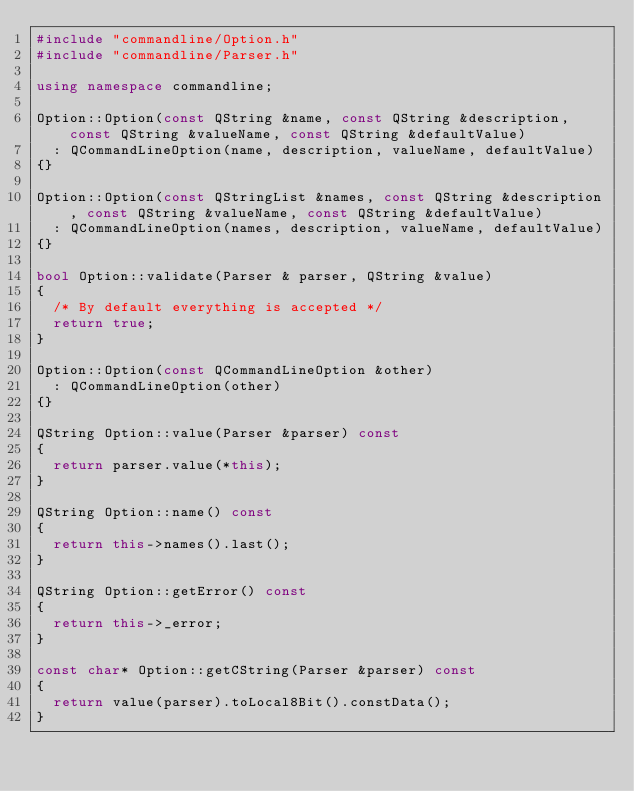Convert code to text. <code><loc_0><loc_0><loc_500><loc_500><_C++_>#include "commandline/Option.h"
#include "commandline/Parser.h"

using namespace commandline;

Option::Option(const QString &name, const QString &description, const QString &valueName, const QString &defaultValue)
	: QCommandLineOption(name, description, valueName, defaultValue)
{}

Option::Option(const QStringList &names, const QString &description, const QString &valueName, const QString &defaultValue)
	: QCommandLineOption(names, description, valueName, defaultValue)
{}

bool Option::validate(Parser & parser, QString &value)
{
	/* By default everything is accepted */
	return true;
}

Option::Option(const QCommandLineOption &other)
	: QCommandLineOption(other)
{}

QString Option::value(Parser &parser) const
{
	return parser.value(*this);
}

QString Option::name() const
{
	return this->names().last();
}

QString Option::getError() const
{
	return this->_error;
}

const char* Option::getCString(Parser &parser) const
{
	return value(parser).toLocal8Bit().constData();
}
</code> 